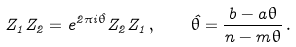<formula> <loc_0><loc_0><loc_500><loc_500>Z _ { 1 } Z _ { 2 } = e ^ { 2 \pi i \hat { \theta } } Z _ { 2 } Z _ { 1 } \, , \quad \hat { \theta } = \frac { b - a \theta } { n - m \theta } \, .</formula> 